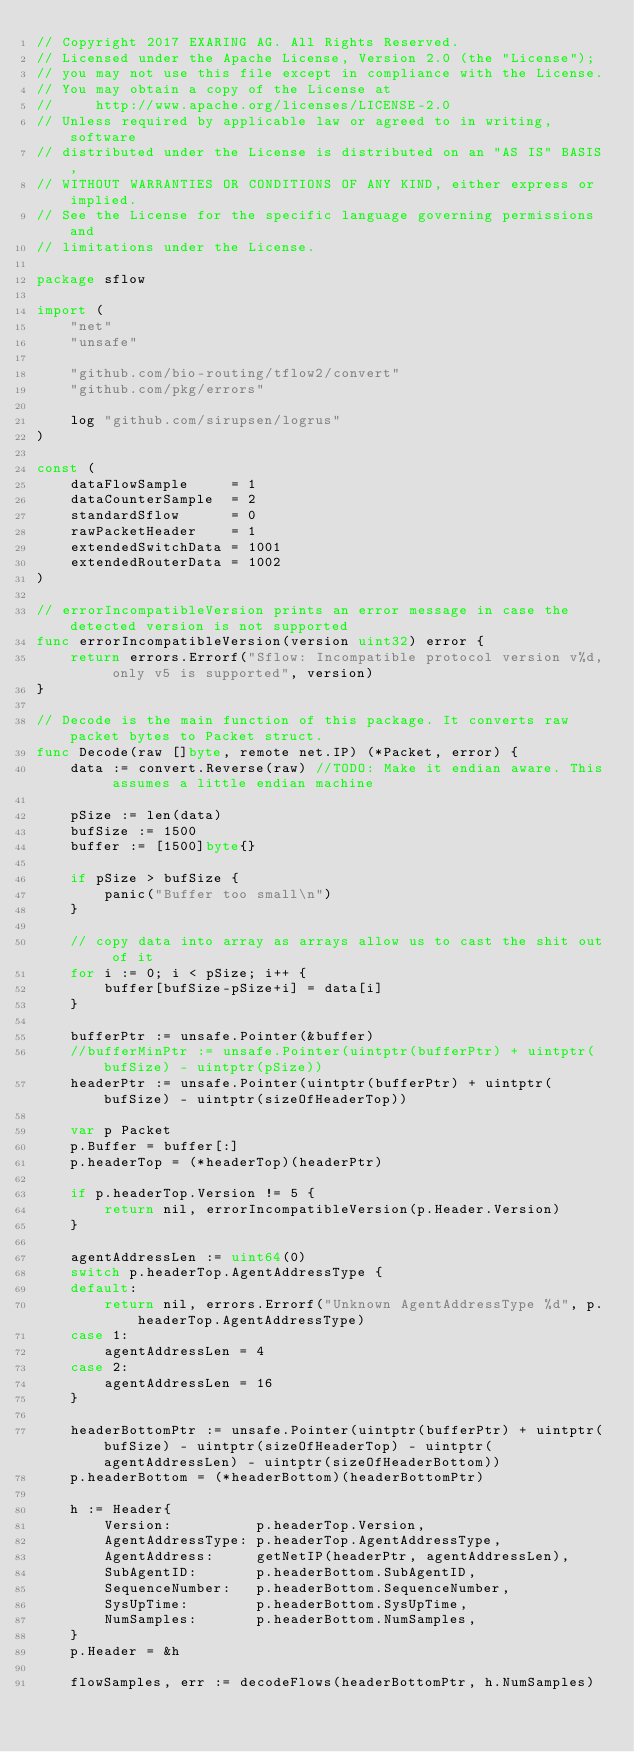<code> <loc_0><loc_0><loc_500><loc_500><_Go_>// Copyright 2017 EXARING AG. All Rights Reserved.
// Licensed under the Apache License, Version 2.0 (the "License");
// you may not use this file except in compliance with the License.
// You may obtain a copy of the License at
//     http://www.apache.org/licenses/LICENSE-2.0
// Unless required by applicable law or agreed to in writing, software
// distributed under the License is distributed on an "AS IS" BASIS,
// WITHOUT WARRANTIES OR CONDITIONS OF ANY KIND, either express or implied.
// See the License for the specific language governing permissions and
// limitations under the License.

package sflow

import (
	"net"
	"unsafe"

	"github.com/bio-routing/tflow2/convert"
	"github.com/pkg/errors"

	log "github.com/sirupsen/logrus"
)

const (
	dataFlowSample     = 1
	dataCounterSample  = 2
	standardSflow      = 0
	rawPacketHeader    = 1
	extendedSwitchData = 1001
	extendedRouterData = 1002
)

// errorIncompatibleVersion prints an error message in case the detected version is not supported
func errorIncompatibleVersion(version uint32) error {
	return errors.Errorf("Sflow: Incompatible protocol version v%d, only v5 is supported", version)
}

// Decode is the main function of this package. It converts raw packet bytes to Packet struct.
func Decode(raw []byte, remote net.IP) (*Packet, error) {
	data := convert.Reverse(raw) //TODO: Make it endian aware. This assumes a little endian machine

	pSize := len(data)
	bufSize := 1500
	buffer := [1500]byte{}

	if pSize > bufSize {
		panic("Buffer too small\n")
	}

	// copy data into array as arrays allow us to cast the shit out of it
	for i := 0; i < pSize; i++ {
		buffer[bufSize-pSize+i] = data[i]
	}

	bufferPtr := unsafe.Pointer(&buffer)
	//bufferMinPtr := unsafe.Pointer(uintptr(bufferPtr) + uintptr(bufSize) - uintptr(pSize))
	headerPtr := unsafe.Pointer(uintptr(bufferPtr) + uintptr(bufSize) - uintptr(sizeOfHeaderTop))

	var p Packet
	p.Buffer = buffer[:]
	p.headerTop = (*headerTop)(headerPtr)

	if p.headerTop.Version != 5 {
		return nil, errorIncompatibleVersion(p.Header.Version)
	}

	agentAddressLen := uint64(0)
	switch p.headerTop.AgentAddressType {
	default:
		return nil, errors.Errorf("Unknown AgentAddressType %d", p.headerTop.AgentAddressType)
	case 1:
		agentAddressLen = 4
	case 2:
		agentAddressLen = 16
	}

	headerBottomPtr := unsafe.Pointer(uintptr(bufferPtr) + uintptr(bufSize) - uintptr(sizeOfHeaderTop) - uintptr(agentAddressLen) - uintptr(sizeOfHeaderBottom))
	p.headerBottom = (*headerBottom)(headerBottomPtr)

	h := Header{
		Version:          p.headerTop.Version,
		AgentAddressType: p.headerTop.AgentAddressType,
		AgentAddress:     getNetIP(headerPtr, agentAddressLen),
		SubAgentID:       p.headerBottom.SubAgentID,
		SequenceNumber:   p.headerBottom.SequenceNumber,
		SysUpTime:        p.headerBottom.SysUpTime,
		NumSamples:       p.headerBottom.NumSamples,
	}
	p.Header = &h

	flowSamples, err := decodeFlows(headerBottomPtr, h.NumSamples)</code> 